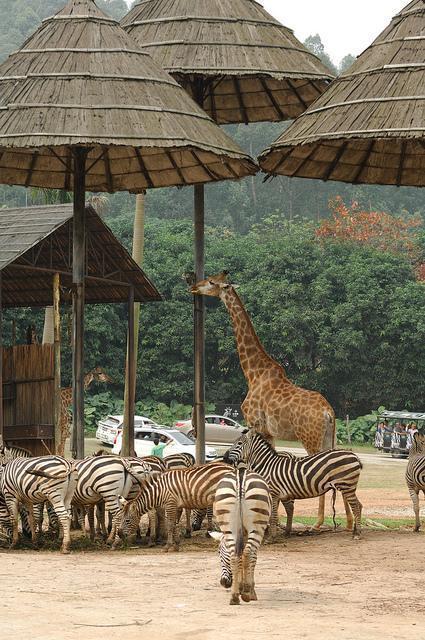How many different kinds of animals are in the picture?
Give a very brief answer. 2. How many umbrellas are in the photo?
Give a very brief answer. 3. How many zebras are visible?
Give a very brief answer. 5. How many cars are in the picture?
Give a very brief answer. 1. 